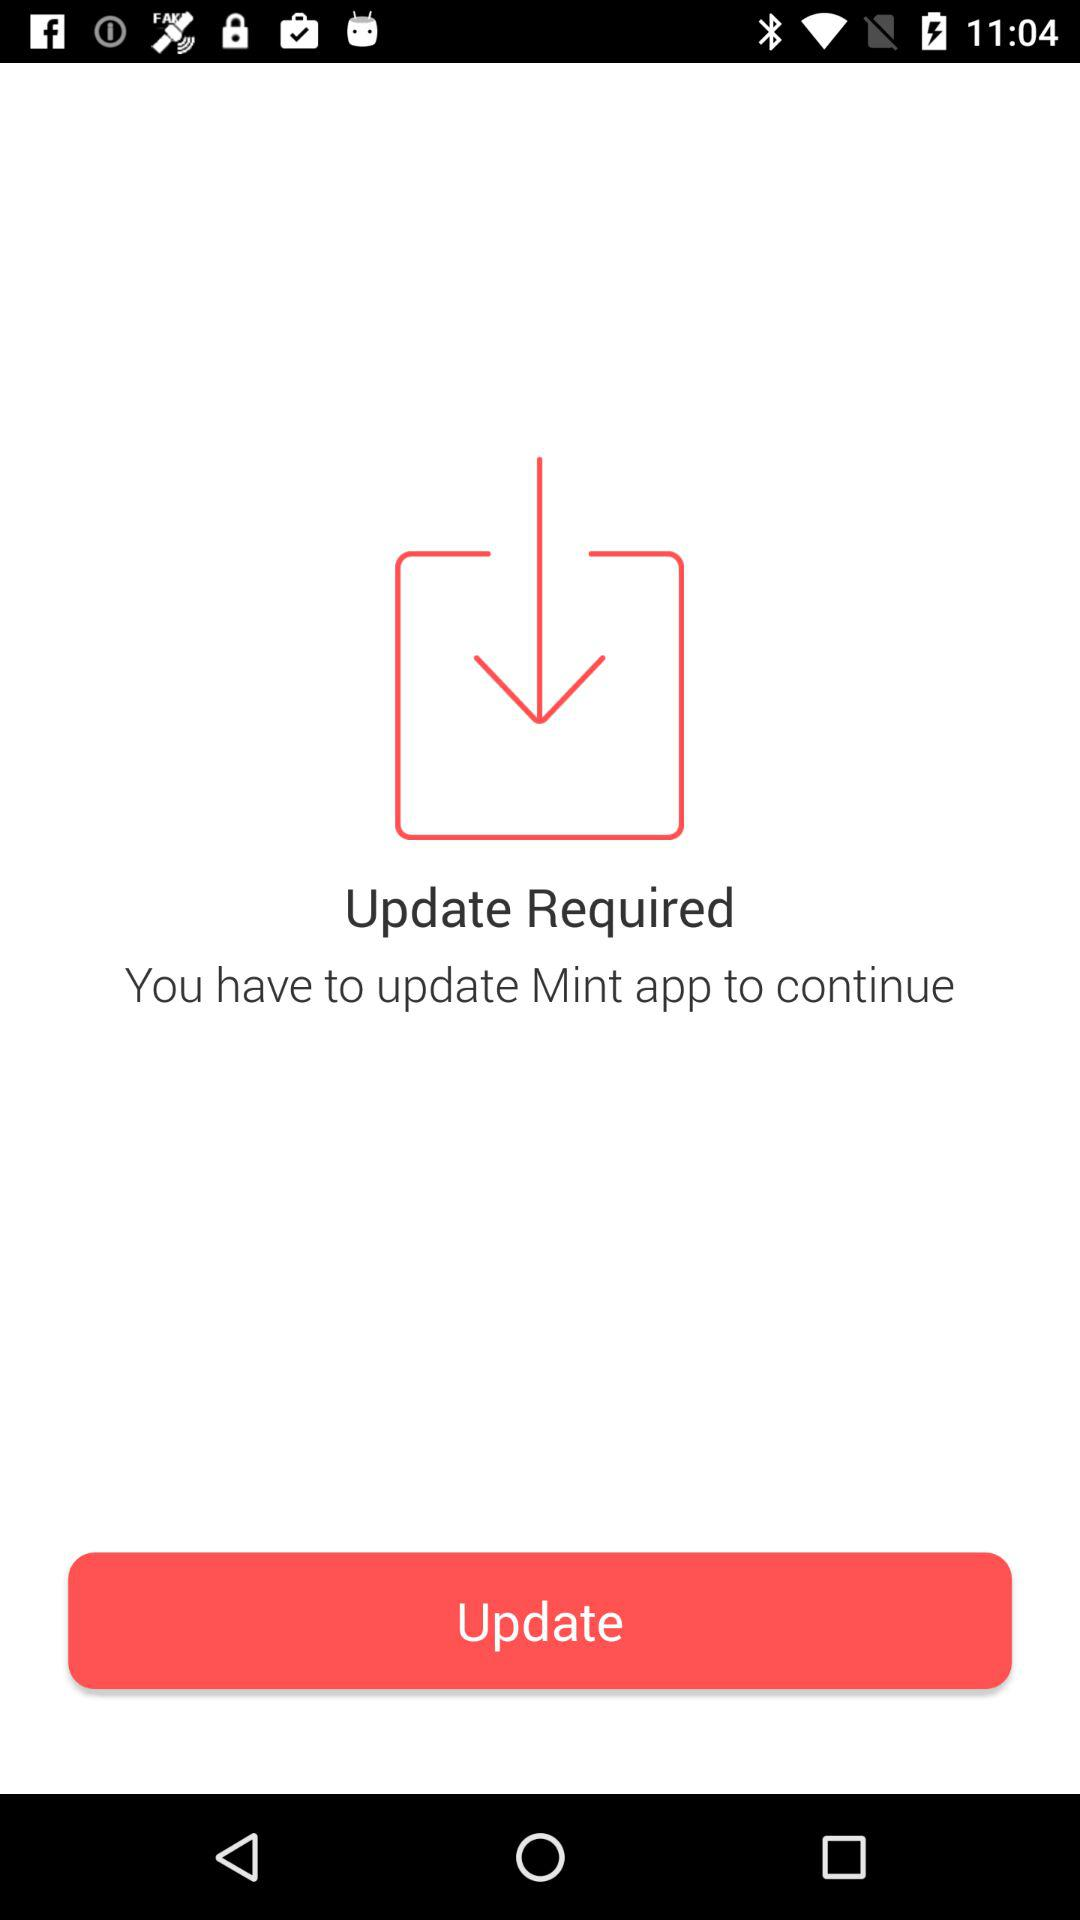What is the application name? The application name is "Mint". 